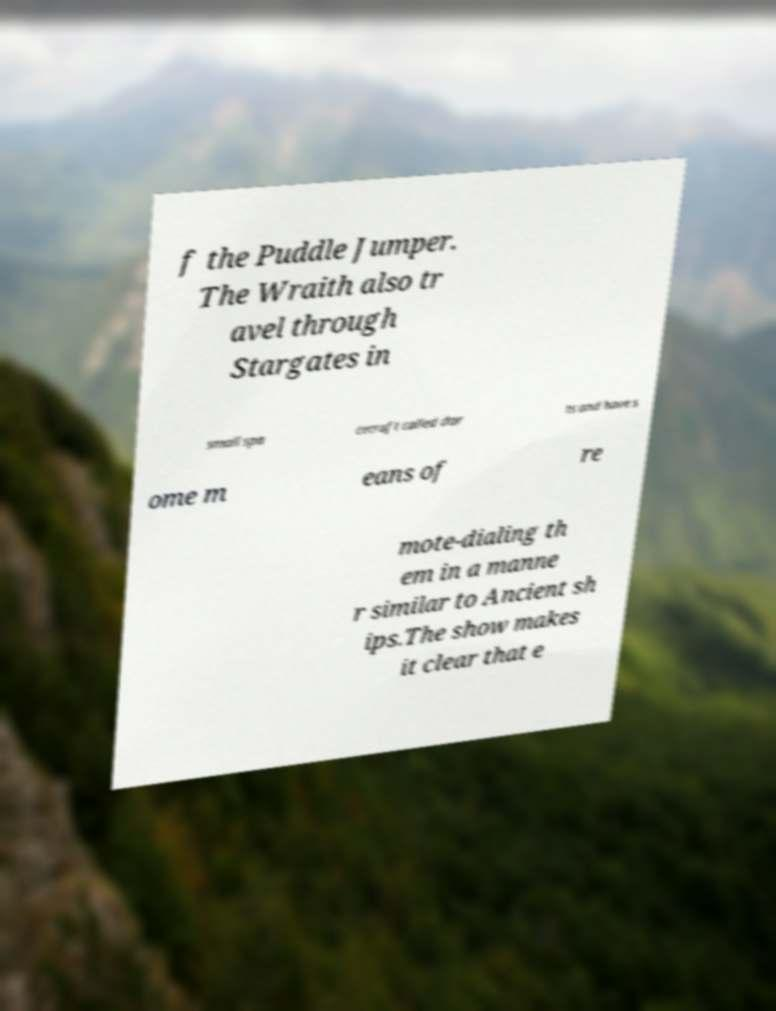For documentation purposes, I need the text within this image transcribed. Could you provide that? f the Puddle Jumper. The Wraith also tr avel through Stargates in small spa cecraft called dar ts and have s ome m eans of re mote-dialing th em in a manne r similar to Ancient sh ips.The show makes it clear that e 